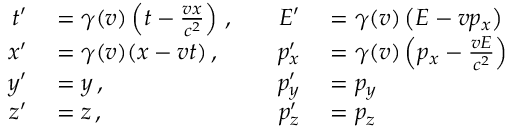Convert formula to latex. <formula><loc_0><loc_0><loc_500><loc_500>\begin{array} { r l r l } { t ^ { \prime } } & = \gamma ( v ) \left ( t - { \frac { v x } { c ^ { 2 } } } \right ) \, , \quad } & { E ^ { \prime } } & = \gamma ( v ) \left ( E - v p _ { x } \right ) } \\ { x ^ { \prime } } & = \gamma ( v ) ( x - v t ) \, , \quad } & { p _ { x } ^ { \prime } } & = \gamma ( v ) \left ( p _ { x } - { \frac { v E } { c ^ { 2 } } } \right ) } \\ { y ^ { \prime } } & = y \, , \quad } & { p _ { y } ^ { \prime } } & = p _ { y } } \\ { z ^ { \prime } } & = z \, , \quad } & { p _ { z } ^ { \prime } } & = p _ { z } } \end{array}</formula> 